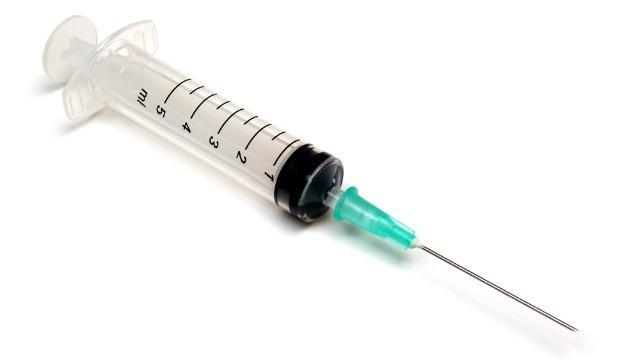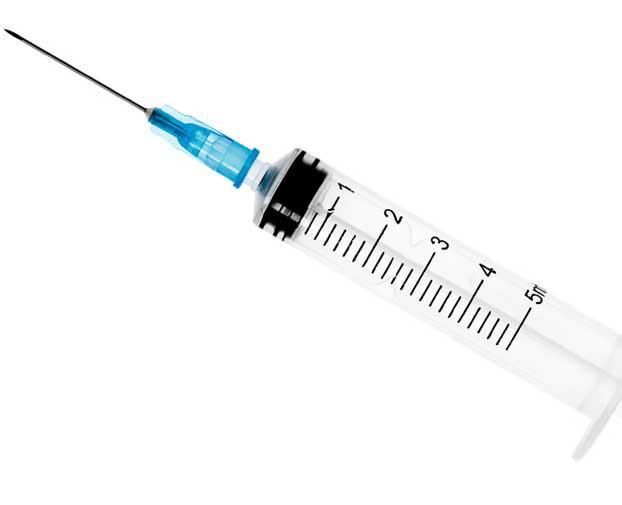The first image is the image on the left, the second image is the image on the right. For the images shown, is this caption "Both images show syringes with needles attached." true? Answer yes or no. Yes. The first image is the image on the left, the second image is the image on the right. For the images shown, is this caption "Both syringes do not have the needle attached." true? Answer yes or no. No. 